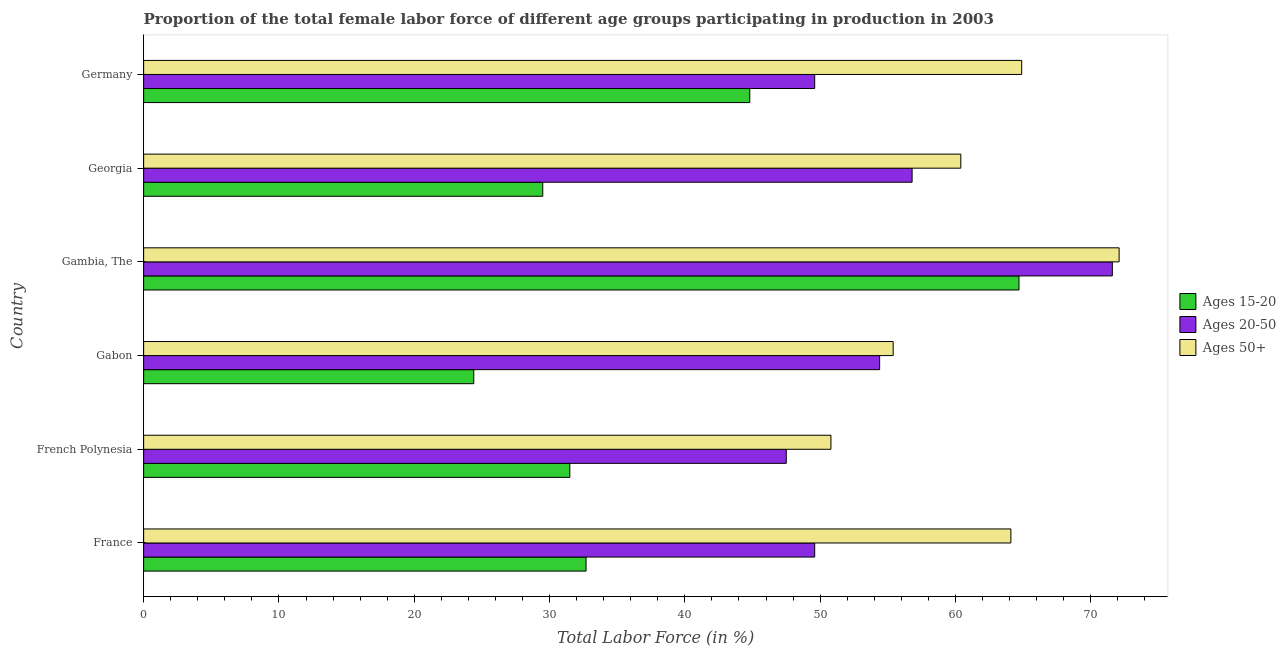How many bars are there on the 4th tick from the top?
Offer a terse response. 3. In how many cases, is the number of bars for a given country not equal to the number of legend labels?
Keep it short and to the point. 0. What is the percentage of female labor force within the age group 20-50 in French Polynesia?
Your answer should be very brief. 47.5. Across all countries, what is the maximum percentage of female labor force within the age group 15-20?
Make the answer very short. 64.7. Across all countries, what is the minimum percentage of female labor force within the age group 20-50?
Offer a terse response. 47.5. In which country was the percentage of female labor force within the age group 15-20 maximum?
Your answer should be compact. Gambia, The. In which country was the percentage of female labor force within the age group 15-20 minimum?
Keep it short and to the point. Gabon. What is the total percentage of female labor force within the age group 15-20 in the graph?
Offer a terse response. 227.6. What is the difference between the percentage of female labor force within the age group 20-50 in Gabon and that in Gambia, The?
Provide a succinct answer. -17.2. What is the difference between the percentage of female labor force above age 50 in French Polynesia and the percentage of female labor force within the age group 20-50 in Gabon?
Your response must be concise. -3.6. What is the average percentage of female labor force within the age group 15-20 per country?
Keep it short and to the point. 37.93. In how many countries, is the percentage of female labor force within the age group 20-50 greater than 68 %?
Offer a terse response. 1. What is the ratio of the percentage of female labor force within the age group 20-50 in France to that in Gambia, The?
Ensure brevity in your answer.  0.69. Is the percentage of female labor force within the age group 15-20 in France less than that in Germany?
Your answer should be compact. Yes. What is the difference between the highest and the second highest percentage of female labor force within the age group 20-50?
Provide a succinct answer. 14.8. What is the difference between the highest and the lowest percentage of female labor force above age 50?
Give a very brief answer. 21.3. Is the sum of the percentage of female labor force above age 50 in Gambia, The and Georgia greater than the maximum percentage of female labor force within the age group 20-50 across all countries?
Ensure brevity in your answer.  Yes. What does the 3rd bar from the top in Georgia represents?
Your answer should be very brief. Ages 15-20. What does the 3rd bar from the bottom in Georgia represents?
Ensure brevity in your answer.  Ages 50+. Is it the case that in every country, the sum of the percentage of female labor force within the age group 15-20 and percentage of female labor force within the age group 20-50 is greater than the percentage of female labor force above age 50?
Provide a short and direct response. Yes. Does the graph contain any zero values?
Provide a short and direct response. No. Does the graph contain grids?
Your answer should be very brief. No. What is the title of the graph?
Ensure brevity in your answer.  Proportion of the total female labor force of different age groups participating in production in 2003. Does "Unpaid family workers" appear as one of the legend labels in the graph?
Offer a very short reply. No. What is the label or title of the Y-axis?
Provide a succinct answer. Country. What is the Total Labor Force (in %) of Ages 15-20 in France?
Your answer should be compact. 32.7. What is the Total Labor Force (in %) of Ages 20-50 in France?
Provide a succinct answer. 49.6. What is the Total Labor Force (in %) in Ages 50+ in France?
Offer a very short reply. 64.1. What is the Total Labor Force (in %) in Ages 15-20 in French Polynesia?
Keep it short and to the point. 31.5. What is the Total Labor Force (in %) of Ages 20-50 in French Polynesia?
Offer a terse response. 47.5. What is the Total Labor Force (in %) of Ages 50+ in French Polynesia?
Make the answer very short. 50.8. What is the Total Labor Force (in %) in Ages 15-20 in Gabon?
Offer a very short reply. 24.4. What is the Total Labor Force (in %) in Ages 20-50 in Gabon?
Your answer should be compact. 54.4. What is the Total Labor Force (in %) in Ages 50+ in Gabon?
Offer a very short reply. 55.4. What is the Total Labor Force (in %) in Ages 15-20 in Gambia, The?
Offer a terse response. 64.7. What is the Total Labor Force (in %) of Ages 20-50 in Gambia, The?
Your response must be concise. 71.6. What is the Total Labor Force (in %) of Ages 50+ in Gambia, The?
Offer a very short reply. 72.1. What is the Total Labor Force (in %) of Ages 15-20 in Georgia?
Give a very brief answer. 29.5. What is the Total Labor Force (in %) in Ages 20-50 in Georgia?
Your answer should be compact. 56.8. What is the Total Labor Force (in %) of Ages 50+ in Georgia?
Your response must be concise. 60.4. What is the Total Labor Force (in %) of Ages 15-20 in Germany?
Offer a terse response. 44.8. What is the Total Labor Force (in %) in Ages 20-50 in Germany?
Offer a very short reply. 49.6. What is the Total Labor Force (in %) in Ages 50+ in Germany?
Make the answer very short. 64.9. Across all countries, what is the maximum Total Labor Force (in %) of Ages 15-20?
Give a very brief answer. 64.7. Across all countries, what is the maximum Total Labor Force (in %) of Ages 20-50?
Your answer should be very brief. 71.6. Across all countries, what is the maximum Total Labor Force (in %) in Ages 50+?
Offer a very short reply. 72.1. Across all countries, what is the minimum Total Labor Force (in %) in Ages 15-20?
Ensure brevity in your answer.  24.4. Across all countries, what is the minimum Total Labor Force (in %) of Ages 20-50?
Your response must be concise. 47.5. Across all countries, what is the minimum Total Labor Force (in %) of Ages 50+?
Your response must be concise. 50.8. What is the total Total Labor Force (in %) of Ages 15-20 in the graph?
Your response must be concise. 227.6. What is the total Total Labor Force (in %) in Ages 20-50 in the graph?
Provide a short and direct response. 329.5. What is the total Total Labor Force (in %) of Ages 50+ in the graph?
Make the answer very short. 367.7. What is the difference between the Total Labor Force (in %) of Ages 50+ in France and that in French Polynesia?
Offer a terse response. 13.3. What is the difference between the Total Labor Force (in %) of Ages 15-20 in France and that in Gabon?
Keep it short and to the point. 8.3. What is the difference between the Total Labor Force (in %) in Ages 15-20 in France and that in Gambia, The?
Offer a very short reply. -32. What is the difference between the Total Labor Force (in %) in Ages 50+ in France and that in Gambia, The?
Keep it short and to the point. -8. What is the difference between the Total Labor Force (in %) in Ages 15-20 in France and that in Georgia?
Make the answer very short. 3.2. What is the difference between the Total Labor Force (in %) in Ages 15-20 in France and that in Germany?
Provide a short and direct response. -12.1. What is the difference between the Total Labor Force (in %) in Ages 15-20 in French Polynesia and that in Gabon?
Your answer should be compact. 7.1. What is the difference between the Total Labor Force (in %) in Ages 20-50 in French Polynesia and that in Gabon?
Keep it short and to the point. -6.9. What is the difference between the Total Labor Force (in %) of Ages 50+ in French Polynesia and that in Gabon?
Offer a very short reply. -4.6. What is the difference between the Total Labor Force (in %) in Ages 15-20 in French Polynesia and that in Gambia, The?
Offer a very short reply. -33.2. What is the difference between the Total Labor Force (in %) in Ages 20-50 in French Polynesia and that in Gambia, The?
Your response must be concise. -24.1. What is the difference between the Total Labor Force (in %) in Ages 50+ in French Polynesia and that in Gambia, The?
Ensure brevity in your answer.  -21.3. What is the difference between the Total Labor Force (in %) in Ages 15-20 in French Polynesia and that in Georgia?
Provide a succinct answer. 2. What is the difference between the Total Labor Force (in %) of Ages 20-50 in French Polynesia and that in Georgia?
Make the answer very short. -9.3. What is the difference between the Total Labor Force (in %) of Ages 50+ in French Polynesia and that in Georgia?
Keep it short and to the point. -9.6. What is the difference between the Total Labor Force (in %) of Ages 20-50 in French Polynesia and that in Germany?
Offer a terse response. -2.1. What is the difference between the Total Labor Force (in %) in Ages 50+ in French Polynesia and that in Germany?
Make the answer very short. -14.1. What is the difference between the Total Labor Force (in %) of Ages 15-20 in Gabon and that in Gambia, The?
Your answer should be very brief. -40.3. What is the difference between the Total Labor Force (in %) in Ages 20-50 in Gabon and that in Gambia, The?
Offer a very short reply. -17.2. What is the difference between the Total Labor Force (in %) of Ages 50+ in Gabon and that in Gambia, The?
Provide a succinct answer. -16.7. What is the difference between the Total Labor Force (in %) of Ages 50+ in Gabon and that in Georgia?
Offer a terse response. -5. What is the difference between the Total Labor Force (in %) of Ages 15-20 in Gabon and that in Germany?
Offer a very short reply. -20.4. What is the difference between the Total Labor Force (in %) in Ages 20-50 in Gabon and that in Germany?
Offer a very short reply. 4.8. What is the difference between the Total Labor Force (in %) of Ages 15-20 in Gambia, The and that in Georgia?
Give a very brief answer. 35.2. What is the difference between the Total Labor Force (in %) of Ages 20-50 in Gambia, The and that in Georgia?
Your answer should be compact. 14.8. What is the difference between the Total Labor Force (in %) in Ages 20-50 in Gambia, The and that in Germany?
Your answer should be very brief. 22. What is the difference between the Total Labor Force (in %) in Ages 15-20 in Georgia and that in Germany?
Your response must be concise. -15.3. What is the difference between the Total Labor Force (in %) in Ages 50+ in Georgia and that in Germany?
Your answer should be compact. -4.5. What is the difference between the Total Labor Force (in %) of Ages 15-20 in France and the Total Labor Force (in %) of Ages 20-50 in French Polynesia?
Give a very brief answer. -14.8. What is the difference between the Total Labor Force (in %) of Ages 15-20 in France and the Total Labor Force (in %) of Ages 50+ in French Polynesia?
Ensure brevity in your answer.  -18.1. What is the difference between the Total Labor Force (in %) of Ages 20-50 in France and the Total Labor Force (in %) of Ages 50+ in French Polynesia?
Your response must be concise. -1.2. What is the difference between the Total Labor Force (in %) in Ages 15-20 in France and the Total Labor Force (in %) in Ages 20-50 in Gabon?
Offer a very short reply. -21.7. What is the difference between the Total Labor Force (in %) in Ages 15-20 in France and the Total Labor Force (in %) in Ages 50+ in Gabon?
Offer a very short reply. -22.7. What is the difference between the Total Labor Force (in %) of Ages 20-50 in France and the Total Labor Force (in %) of Ages 50+ in Gabon?
Offer a very short reply. -5.8. What is the difference between the Total Labor Force (in %) in Ages 15-20 in France and the Total Labor Force (in %) in Ages 20-50 in Gambia, The?
Give a very brief answer. -38.9. What is the difference between the Total Labor Force (in %) of Ages 15-20 in France and the Total Labor Force (in %) of Ages 50+ in Gambia, The?
Your answer should be compact. -39.4. What is the difference between the Total Labor Force (in %) in Ages 20-50 in France and the Total Labor Force (in %) in Ages 50+ in Gambia, The?
Offer a terse response. -22.5. What is the difference between the Total Labor Force (in %) of Ages 15-20 in France and the Total Labor Force (in %) of Ages 20-50 in Georgia?
Provide a short and direct response. -24.1. What is the difference between the Total Labor Force (in %) of Ages 15-20 in France and the Total Labor Force (in %) of Ages 50+ in Georgia?
Give a very brief answer. -27.7. What is the difference between the Total Labor Force (in %) in Ages 20-50 in France and the Total Labor Force (in %) in Ages 50+ in Georgia?
Ensure brevity in your answer.  -10.8. What is the difference between the Total Labor Force (in %) of Ages 15-20 in France and the Total Labor Force (in %) of Ages 20-50 in Germany?
Your response must be concise. -16.9. What is the difference between the Total Labor Force (in %) of Ages 15-20 in France and the Total Labor Force (in %) of Ages 50+ in Germany?
Keep it short and to the point. -32.2. What is the difference between the Total Labor Force (in %) in Ages 20-50 in France and the Total Labor Force (in %) in Ages 50+ in Germany?
Make the answer very short. -15.3. What is the difference between the Total Labor Force (in %) in Ages 15-20 in French Polynesia and the Total Labor Force (in %) in Ages 20-50 in Gabon?
Offer a terse response. -22.9. What is the difference between the Total Labor Force (in %) in Ages 15-20 in French Polynesia and the Total Labor Force (in %) in Ages 50+ in Gabon?
Ensure brevity in your answer.  -23.9. What is the difference between the Total Labor Force (in %) of Ages 20-50 in French Polynesia and the Total Labor Force (in %) of Ages 50+ in Gabon?
Provide a succinct answer. -7.9. What is the difference between the Total Labor Force (in %) of Ages 15-20 in French Polynesia and the Total Labor Force (in %) of Ages 20-50 in Gambia, The?
Give a very brief answer. -40.1. What is the difference between the Total Labor Force (in %) of Ages 15-20 in French Polynesia and the Total Labor Force (in %) of Ages 50+ in Gambia, The?
Provide a succinct answer. -40.6. What is the difference between the Total Labor Force (in %) in Ages 20-50 in French Polynesia and the Total Labor Force (in %) in Ages 50+ in Gambia, The?
Provide a succinct answer. -24.6. What is the difference between the Total Labor Force (in %) in Ages 15-20 in French Polynesia and the Total Labor Force (in %) in Ages 20-50 in Georgia?
Give a very brief answer. -25.3. What is the difference between the Total Labor Force (in %) of Ages 15-20 in French Polynesia and the Total Labor Force (in %) of Ages 50+ in Georgia?
Your response must be concise. -28.9. What is the difference between the Total Labor Force (in %) of Ages 15-20 in French Polynesia and the Total Labor Force (in %) of Ages 20-50 in Germany?
Provide a succinct answer. -18.1. What is the difference between the Total Labor Force (in %) in Ages 15-20 in French Polynesia and the Total Labor Force (in %) in Ages 50+ in Germany?
Offer a very short reply. -33.4. What is the difference between the Total Labor Force (in %) in Ages 20-50 in French Polynesia and the Total Labor Force (in %) in Ages 50+ in Germany?
Provide a short and direct response. -17.4. What is the difference between the Total Labor Force (in %) of Ages 15-20 in Gabon and the Total Labor Force (in %) of Ages 20-50 in Gambia, The?
Your answer should be very brief. -47.2. What is the difference between the Total Labor Force (in %) of Ages 15-20 in Gabon and the Total Labor Force (in %) of Ages 50+ in Gambia, The?
Keep it short and to the point. -47.7. What is the difference between the Total Labor Force (in %) of Ages 20-50 in Gabon and the Total Labor Force (in %) of Ages 50+ in Gambia, The?
Your answer should be compact. -17.7. What is the difference between the Total Labor Force (in %) of Ages 15-20 in Gabon and the Total Labor Force (in %) of Ages 20-50 in Georgia?
Offer a very short reply. -32.4. What is the difference between the Total Labor Force (in %) of Ages 15-20 in Gabon and the Total Labor Force (in %) of Ages 50+ in Georgia?
Provide a short and direct response. -36. What is the difference between the Total Labor Force (in %) in Ages 20-50 in Gabon and the Total Labor Force (in %) in Ages 50+ in Georgia?
Make the answer very short. -6. What is the difference between the Total Labor Force (in %) in Ages 15-20 in Gabon and the Total Labor Force (in %) in Ages 20-50 in Germany?
Provide a succinct answer. -25.2. What is the difference between the Total Labor Force (in %) of Ages 15-20 in Gabon and the Total Labor Force (in %) of Ages 50+ in Germany?
Your response must be concise. -40.5. What is the difference between the Total Labor Force (in %) in Ages 20-50 in Gambia, The and the Total Labor Force (in %) in Ages 50+ in Georgia?
Ensure brevity in your answer.  11.2. What is the difference between the Total Labor Force (in %) of Ages 15-20 in Gambia, The and the Total Labor Force (in %) of Ages 20-50 in Germany?
Provide a succinct answer. 15.1. What is the difference between the Total Labor Force (in %) of Ages 15-20 in Gambia, The and the Total Labor Force (in %) of Ages 50+ in Germany?
Keep it short and to the point. -0.2. What is the difference between the Total Labor Force (in %) in Ages 20-50 in Gambia, The and the Total Labor Force (in %) in Ages 50+ in Germany?
Your answer should be very brief. 6.7. What is the difference between the Total Labor Force (in %) of Ages 15-20 in Georgia and the Total Labor Force (in %) of Ages 20-50 in Germany?
Give a very brief answer. -20.1. What is the difference between the Total Labor Force (in %) of Ages 15-20 in Georgia and the Total Labor Force (in %) of Ages 50+ in Germany?
Offer a very short reply. -35.4. What is the difference between the Total Labor Force (in %) in Ages 20-50 in Georgia and the Total Labor Force (in %) in Ages 50+ in Germany?
Offer a terse response. -8.1. What is the average Total Labor Force (in %) in Ages 15-20 per country?
Make the answer very short. 37.93. What is the average Total Labor Force (in %) of Ages 20-50 per country?
Give a very brief answer. 54.92. What is the average Total Labor Force (in %) in Ages 50+ per country?
Provide a succinct answer. 61.28. What is the difference between the Total Labor Force (in %) in Ages 15-20 and Total Labor Force (in %) in Ages 20-50 in France?
Provide a short and direct response. -16.9. What is the difference between the Total Labor Force (in %) in Ages 15-20 and Total Labor Force (in %) in Ages 50+ in France?
Ensure brevity in your answer.  -31.4. What is the difference between the Total Labor Force (in %) of Ages 20-50 and Total Labor Force (in %) of Ages 50+ in France?
Give a very brief answer. -14.5. What is the difference between the Total Labor Force (in %) of Ages 15-20 and Total Labor Force (in %) of Ages 50+ in French Polynesia?
Keep it short and to the point. -19.3. What is the difference between the Total Labor Force (in %) in Ages 15-20 and Total Labor Force (in %) in Ages 50+ in Gabon?
Keep it short and to the point. -31. What is the difference between the Total Labor Force (in %) of Ages 20-50 and Total Labor Force (in %) of Ages 50+ in Gabon?
Your answer should be very brief. -1. What is the difference between the Total Labor Force (in %) in Ages 15-20 and Total Labor Force (in %) in Ages 20-50 in Georgia?
Provide a succinct answer. -27.3. What is the difference between the Total Labor Force (in %) of Ages 15-20 and Total Labor Force (in %) of Ages 50+ in Georgia?
Give a very brief answer. -30.9. What is the difference between the Total Labor Force (in %) of Ages 20-50 and Total Labor Force (in %) of Ages 50+ in Georgia?
Provide a short and direct response. -3.6. What is the difference between the Total Labor Force (in %) in Ages 15-20 and Total Labor Force (in %) in Ages 50+ in Germany?
Provide a short and direct response. -20.1. What is the difference between the Total Labor Force (in %) of Ages 20-50 and Total Labor Force (in %) of Ages 50+ in Germany?
Provide a short and direct response. -15.3. What is the ratio of the Total Labor Force (in %) in Ages 15-20 in France to that in French Polynesia?
Offer a terse response. 1.04. What is the ratio of the Total Labor Force (in %) of Ages 20-50 in France to that in French Polynesia?
Keep it short and to the point. 1.04. What is the ratio of the Total Labor Force (in %) in Ages 50+ in France to that in French Polynesia?
Your response must be concise. 1.26. What is the ratio of the Total Labor Force (in %) of Ages 15-20 in France to that in Gabon?
Your response must be concise. 1.34. What is the ratio of the Total Labor Force (in %) in Ages 20-50 in France to that in Gabon?
Keep it short and to the point. 0.91. What is the ratio of the Total Labor Force (in %) in Ages 50+ in France to that in Gabon?
Ensure brevity in your answer.  1.16. What is the ratio of the Total Labor Force (in %) of Ages 15-20 in France to that in Gambia, The?
Your answer should be compact. 0.51. What is the ratio of the Total Labor Force (in %) of Ages 20-50 in France to that in Gambia, The?
Offer a very short reply. 0.69. What is the ratio of the Total Labor Force (in %) in Ages 50+ in France to that in Gambia, The?
Your answer should be very brief. 0.89. What is the ratio of the Total Labor Force (in %) of Ages 15-20 in France to that in Georgia?
Provide a short and direct response. 1.11. What is the ratio of the Total Labor Force (in %) of Ages 20-50 in France to that in Georgia?
Provide a short and direct response. 0.87. What is the ratio of the Total Labor Force (in %) in Ages 50+ in France to that in Georgia?
Your response must be concise. 1.06. What is the ratio of the Total Labor Force (in %) of Ages 15-20 in France to that in Germany?
Provide a short and direct response. 0.73. What is the ratio of the Total Labor Force (in %) in Ages 20-50 in France to that in Germany?
Your answer should be compact. 1. What is the ratio of the Total Labor Force (in %) of Ages 50+ in France to that in Germany?
Provide a succinct answer. 0.99. What is the ratio of the Total Labor Force (in %) of Ages 15-20 in French Polynesia to that in Gabon?
Your response must be concise. 1.29. What is the ratio of the Total Labor Force (in %) of Ages 20-50 in French Polynesia to that in Gabon?
Offer a terse response. 0.87. What is the ratio of the Total Labor Force (in %) in Ages 50+ in French Polynesia to that in Gabon?
Your answer should be very brief. 0.92. What is the ratio of the Total Labor Force (in %) in Ages 15-20 in French Polynesia to that in Gambia, The?
Your answer should be compact. 0.49. What is the ratio of the Total Labor Force (in %) of Ages 20-50 in French Polynesia to that in Gambia, The?
Your response must be concise. 0.66. What is the ratio of the Total Labor Force (in %) of Ages 50+ in French Polynesia to that in Gambia, The?
Provide a succinct answer. 0.7. What is the ratio of the Total Labor Force (in %) in Ages 15-20 in French Polynesia to that in Georgia?
Give a very brief answer. 1.07. What is the ratio of the Total Labor Force (in %) of Ages 20-50 in French Polynesia to that in Georgia?
Make the answer very short. 0.84. What is the ratio of the Total Labor Force (in %) of Ages 50+ in French Polynesia to that in Georgia?
Keep it short and to the point. 0.84. What is the ratio of the Total Labor Force (in %) of Ages 15-20 in French Polynesia to that in Germany?
Make the answer very short. 0.7. What is the ratio of the Total Labor Force (in %) of Ages 20-50 in French Polynesia to that in Germany?
Offer a terse response. 0.96. What is the ratio of the Total Labor Force (in %) of Ages 50+ in French Polynesia to that in Germany?
Your answer should be very brief. 0.78. What is the ratio of the Total Labor Force (in %) of Ages 15-20 in Gabon to that in Gambia, The?
Offer a terse response. 0.38. What is the ratio of the Total Labor Force (in %) of Ages 20-50 in Gabon to that in Gambia, The?
Give a very brief answer. 0.76. What is the ratio of the Total Labor Force (in %) of Ages 50+ in Gabon to that in Gambia, The?
Provide a succinct answer. 0.77. What is the ratio of the Total Labor Force (in %) in Ages 15-20 in Gabon to that in Georgia?
Ensure brevity in your answer.  0.83. What is the ratio of the Total Labor Force (in %) in Ages 20-50 in Gabon to that in Georgia?
Your response must be concise. 0.96. What is the ratio of the Total Labor Force (in %) of Ages 50+ in Gabon to that in Georgia?
Offer a very short reply. 0.92. What is the ratio of the Total Labor Force (in %) in Ages 15-20 in Gabon to that in Germany?
Provide a succinct answer. 0.54. What is the ratio of the Total Labor Force (in %) of Ages 20-50 in Gabon to that in Germany?
Provide a succinct answer. 1.1. What is the ratio of the Total Labor Force (in %) of Ages 50+ in Gabon to that in Germany?
Keep it short and to the point. 0.85. What is the ratio of the Total Labor Force (in %) of Ages 15-20 in Gambia, The to that in Georgia?
Ensure brevity in your answer.  2.19. What is the ratio of the Total Labor Force (in %) of Ages 20-50 in Gambia, The to that in Georgia?
Give a very brief answer. 1.26. What is the ratio of the Total Labor Force (in %) of Ages 50+ in Gambia, The to that in Georgia?
Provide a succinct answer. 1.19. What is the ratio of the Total Labor Force (in %) of Ages 15-20 in Gambia, The to that in Germany?
Offer a very short reply. 1.44. What is the ratio of the Total Labor Force (in %) in Ages 20-50 in Gambia, The to that in Germany?
Keep it short and to the point. 1.44. What is the ratio of the Total Labor Force (in %) of Ages 50+ in Gambia, The to that in Germany?
Your response must be concise. 1.11. What is the ratio of the Total Labor Force (in %) in Ages 15-20 in Georgia to that in Germany?
Offer a terse response. 0.66. What is the ratio of the Total Labor Force (in %) in Ages 20-50 in Georgia to that in Germany?
Your answer should be very brief. 1.15. What is the ratio of the Total Labor Force (in %) in Ages 50+ in Georgia to that in Germany?
Provide a succinct answer. 0.93. What is the difference between the highest and the second highest Total Labor Force (in %) of Ages 20-50?
Your response must be concise. 14.8. What is the difference between the highest and the second highest Total Labor Force (in %) in Ages 50+?
Provide a short and direct response. 7.2. What is the difference between the highest and the lowest Total Labor Force (in %) of Ages 15-20?
Make the answer very short. 40.3. What is the difference between the highest and the lowest Total Labor Force (in %) in Ages 20-50?
Provide a short and direct response. 24.1. What is the difference between the highest and the lowest Total Labor Force (in %) in Ages 50+?
Your answer should be very brief. 21.3. 